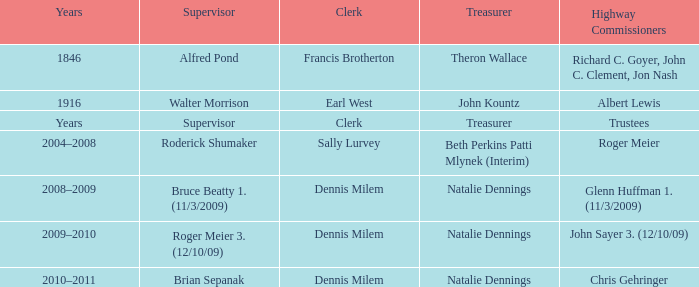Who served as the clerk when albert lewis was the highway commissioner? Earl West. 